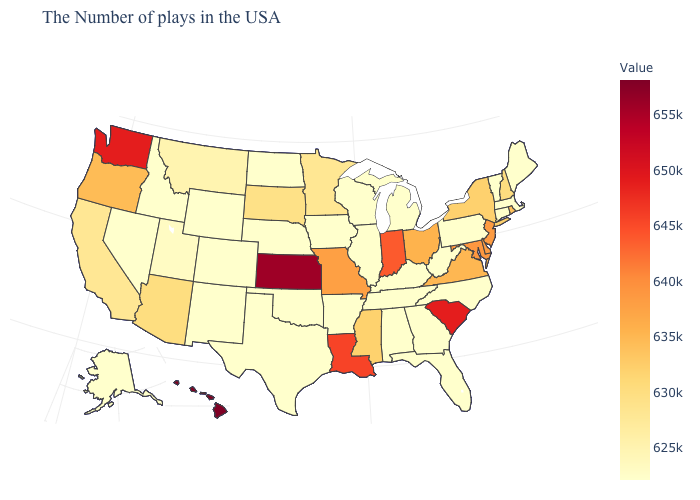Which states hav the highest value in the West?
Keep it brief. Hawaii. Among the states that border Nebraska , does South Dakota have the lowest value?
Short answer required. No. Is the legend a continuous bar?
Quick response, please. Yes. Which states hav the highest value in the West?
Give a very brief answer. Hawaii. Among the states that border Idaho , does Nevada have the lowest value?
Give a very brief answer. Yes. Among the states that border Nebraska , does Missouri have the lowest value?
Write a very short answer. No. 